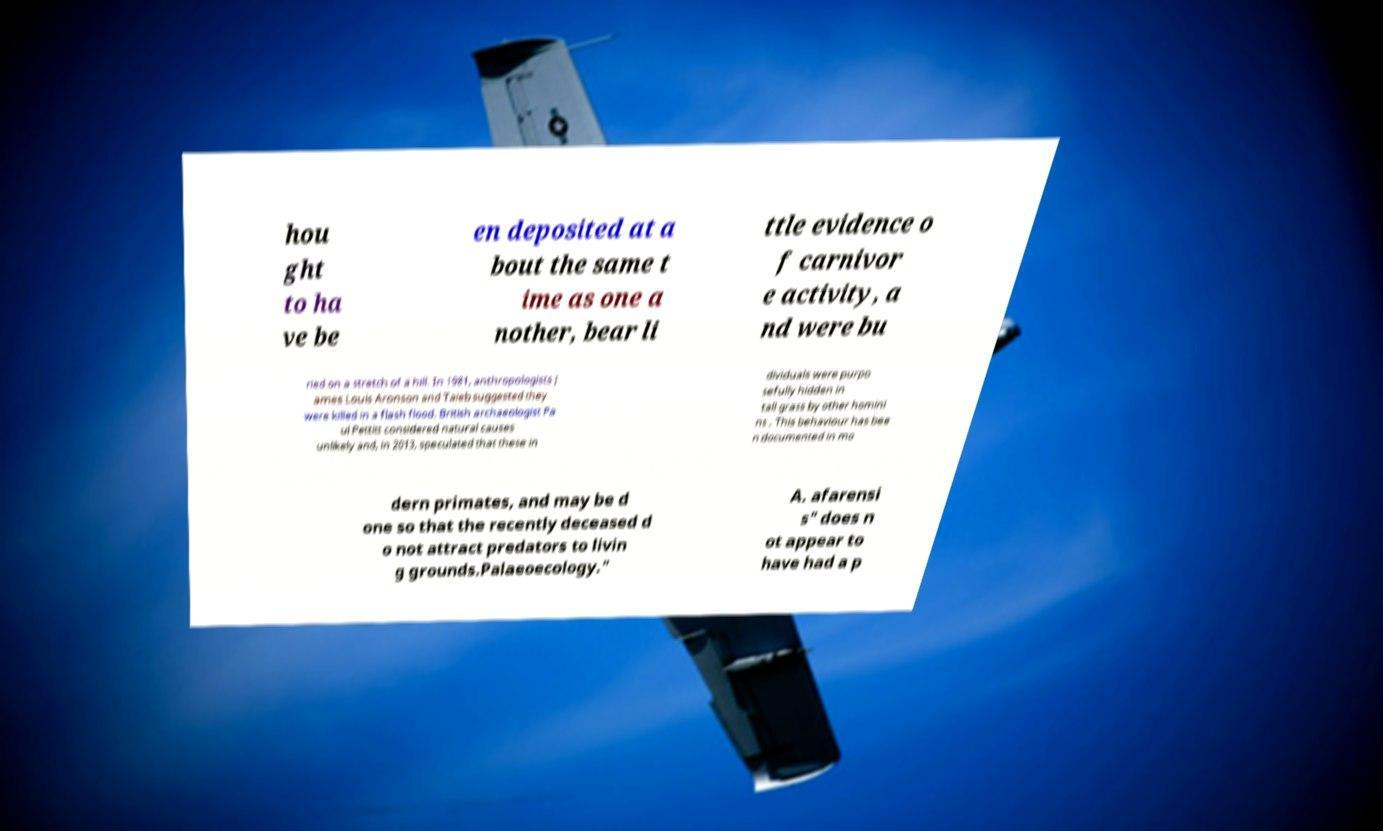Can you read and provide the text displayed in the image?This photo seems to have some interesting text. Can you extract and type it out for me? hou ght to ha ve be en deposited at a bout the same t ime as one a nother, bear li ttle evidence o f carnivor e activity, a nd were bu ried on a stretch of a hill. In 1981, anthropologists J ames Louis Aronson and Taieb suggested they were killed in a flash flood. British archaeologist Pa ul Pettitt considered natural causes unlikely and, in 2013, speculated that these in dividuals were purpo sefully hidden in tall grass by other homini ns . This behaviour has bee n documented in mo dern primates, and may be d one so that the recently deceased d o not attract predators to livin g grounds.Palaeoecology." A. afarensi s" does n ot appear to have had a p 